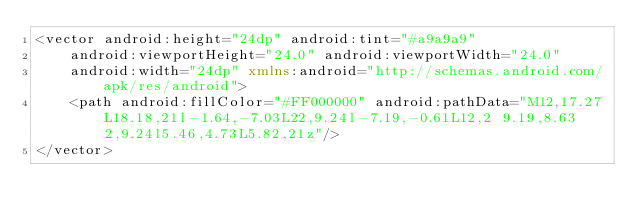Convert code to text. <code><loc_0><loc_0><loc_500><loc_500><_XML_><vector android:height="24dp" android:tint="#a9a9a9"
    android:viewportHeight="24.0" android:viewportWidth="24.0"
    android:width="24dp" xmlns:android="http://schemas.android.com/apk/res/android">
    <path android:fillColor="#FF000000" android:pathData="M12,17.27L18.18,21l-1.64,-7.03L22,9.24l-7.19,-0.61L12,2 9.19,8.63 2,9.24l5.46,4.73L5.82,21z"/>
</vector>
</code> 